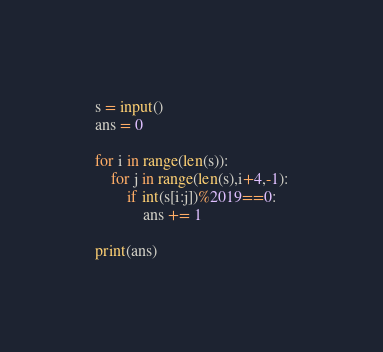<code> <loc_0><loc_0><loc_500><loc_500><_Python_>s = input()
ans = 0

for i in range(len(s)):
    for j in range(len(s),i+4,-1):
        if int(s[i:j])%2019==0:
            ans += 1

print(ans)
</code> 